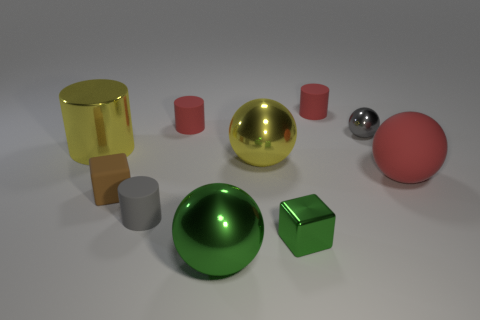Subtract 1 balls. How many balls are left? 3 Subtract all spheres. How many objects are left? 6 Add 10 brown metal cylinders. How many brown metal cylinders exist? 10 Subtract 1 red balls. How many objects are left? 9 Subtract all green metal balls. Subtract all tiny rubber objects. How many objects are left? 5 Add 3 small gray shiny objects. How many small gray shiny objects are left? 4 